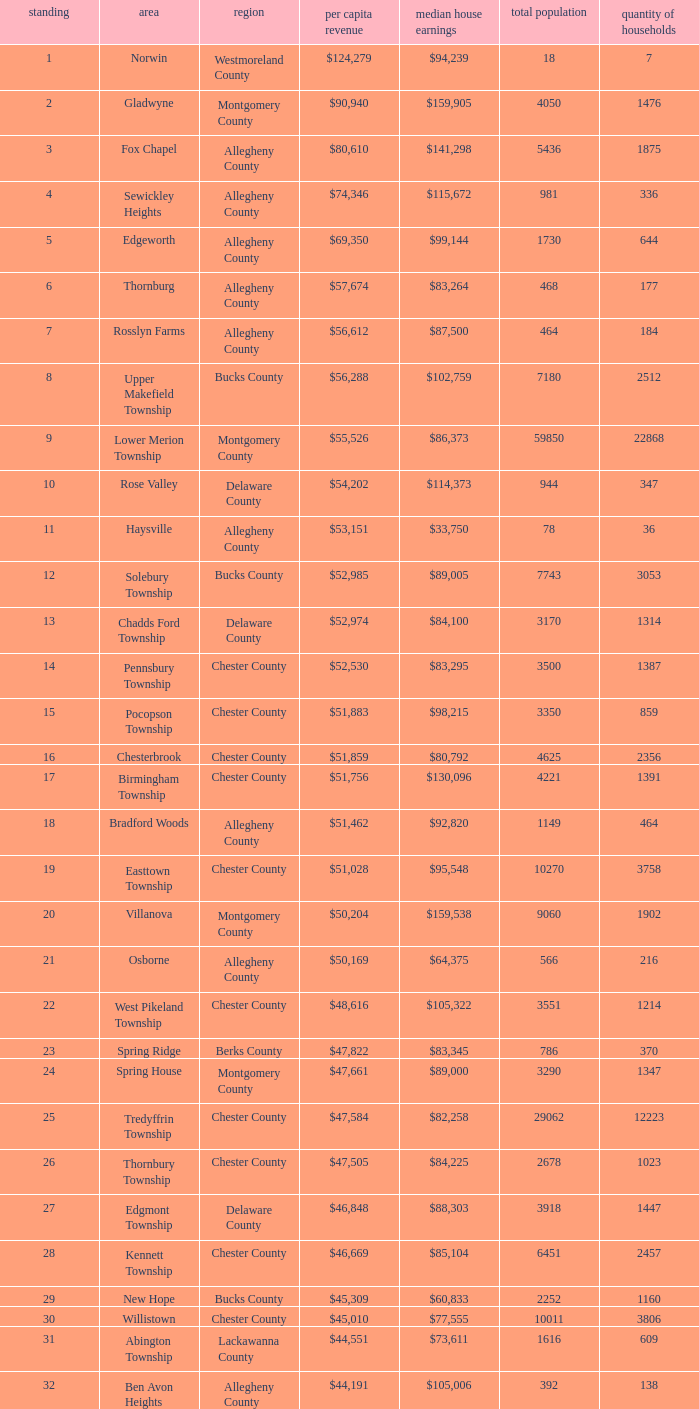Which place has a rank of 71? Wyomissing. 